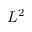Convert formula to latex. <formula><loc_0><loc_0><loc_500><loc_500>L ^ { 2 }</formula> 